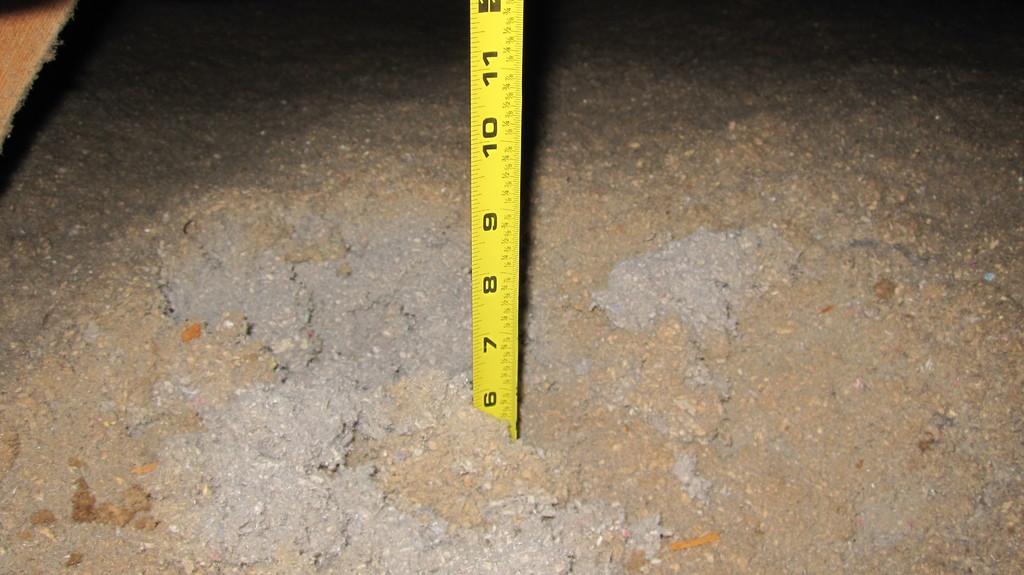Which number is closest to the ground?
Your response must be concise. 6. 